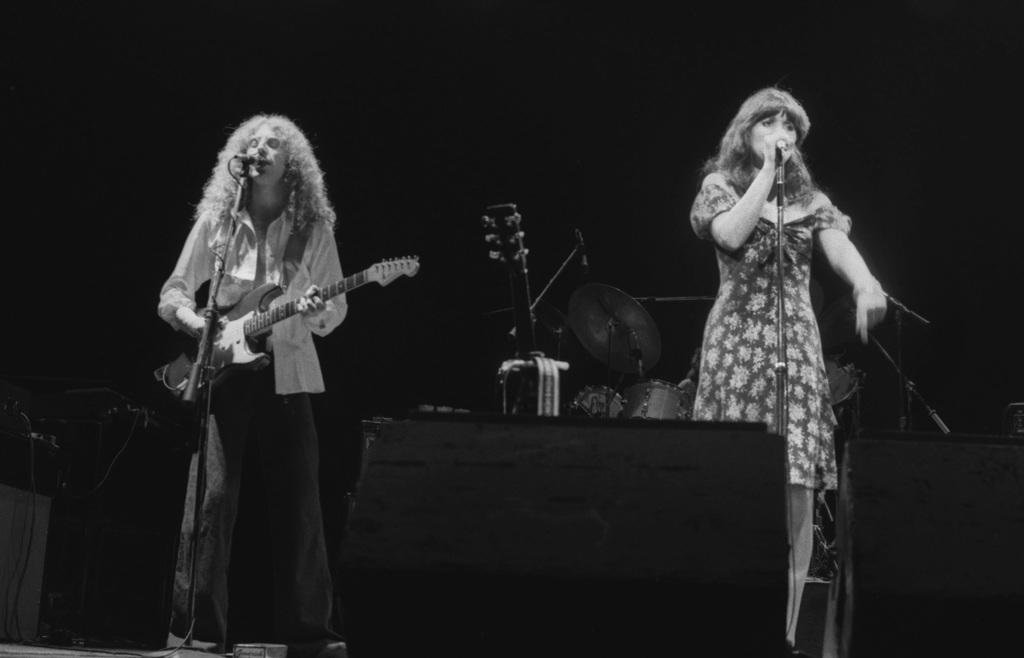What is happening in the image? There are two people standing on a stage. What is the man holding in his hand? The man is holding a guitar in his hand. What type of pancake is the man holding in his hand? The man is not holding a pancake in his hand; he is holding a guitar. Can you see the man's smile in the image? The provided facts do not mention the man's facial expression, so it cannot be determined from the image. 